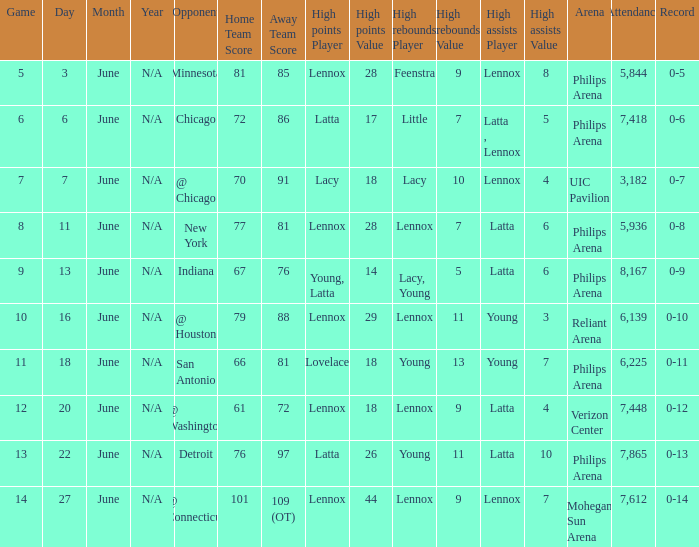Who made the highest assist in the game that scored 79-88? Young (3). 